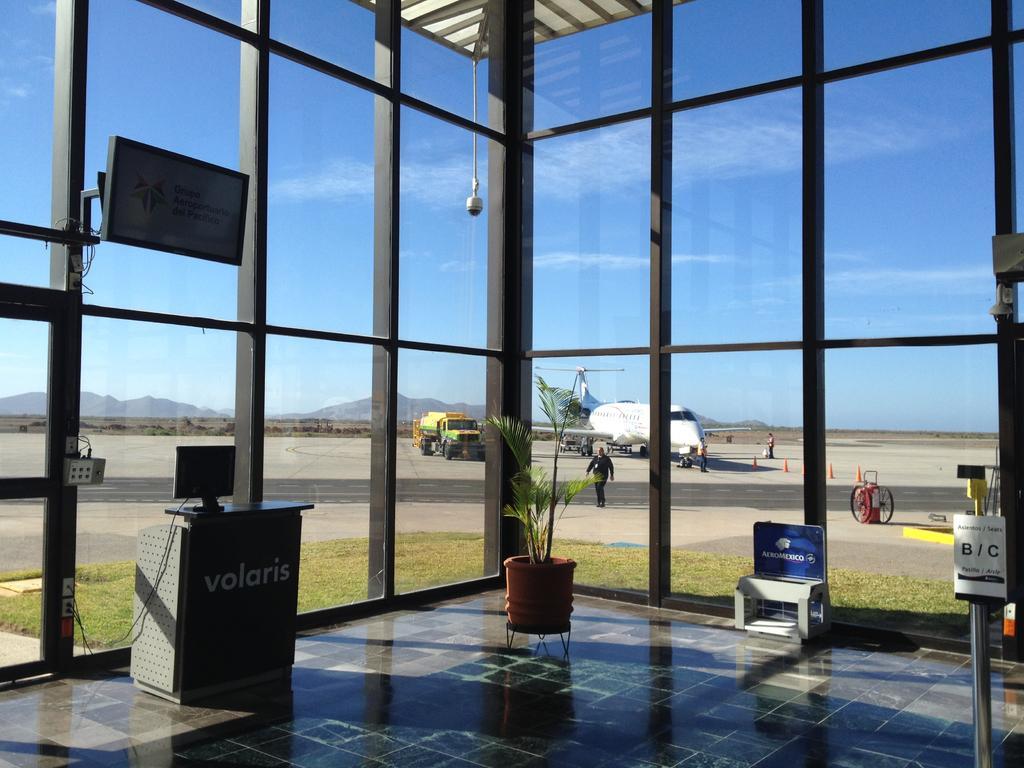Describe this image in one or two sentences. This image is taken in the building. In the center of the image we can see a houseplant and there are boards. On the left there is a screen placed on the stand. We can see a television placed on the glass door. In the background we can see a vehicle, people, an aeroplane, hills and sky through the glass doors. 